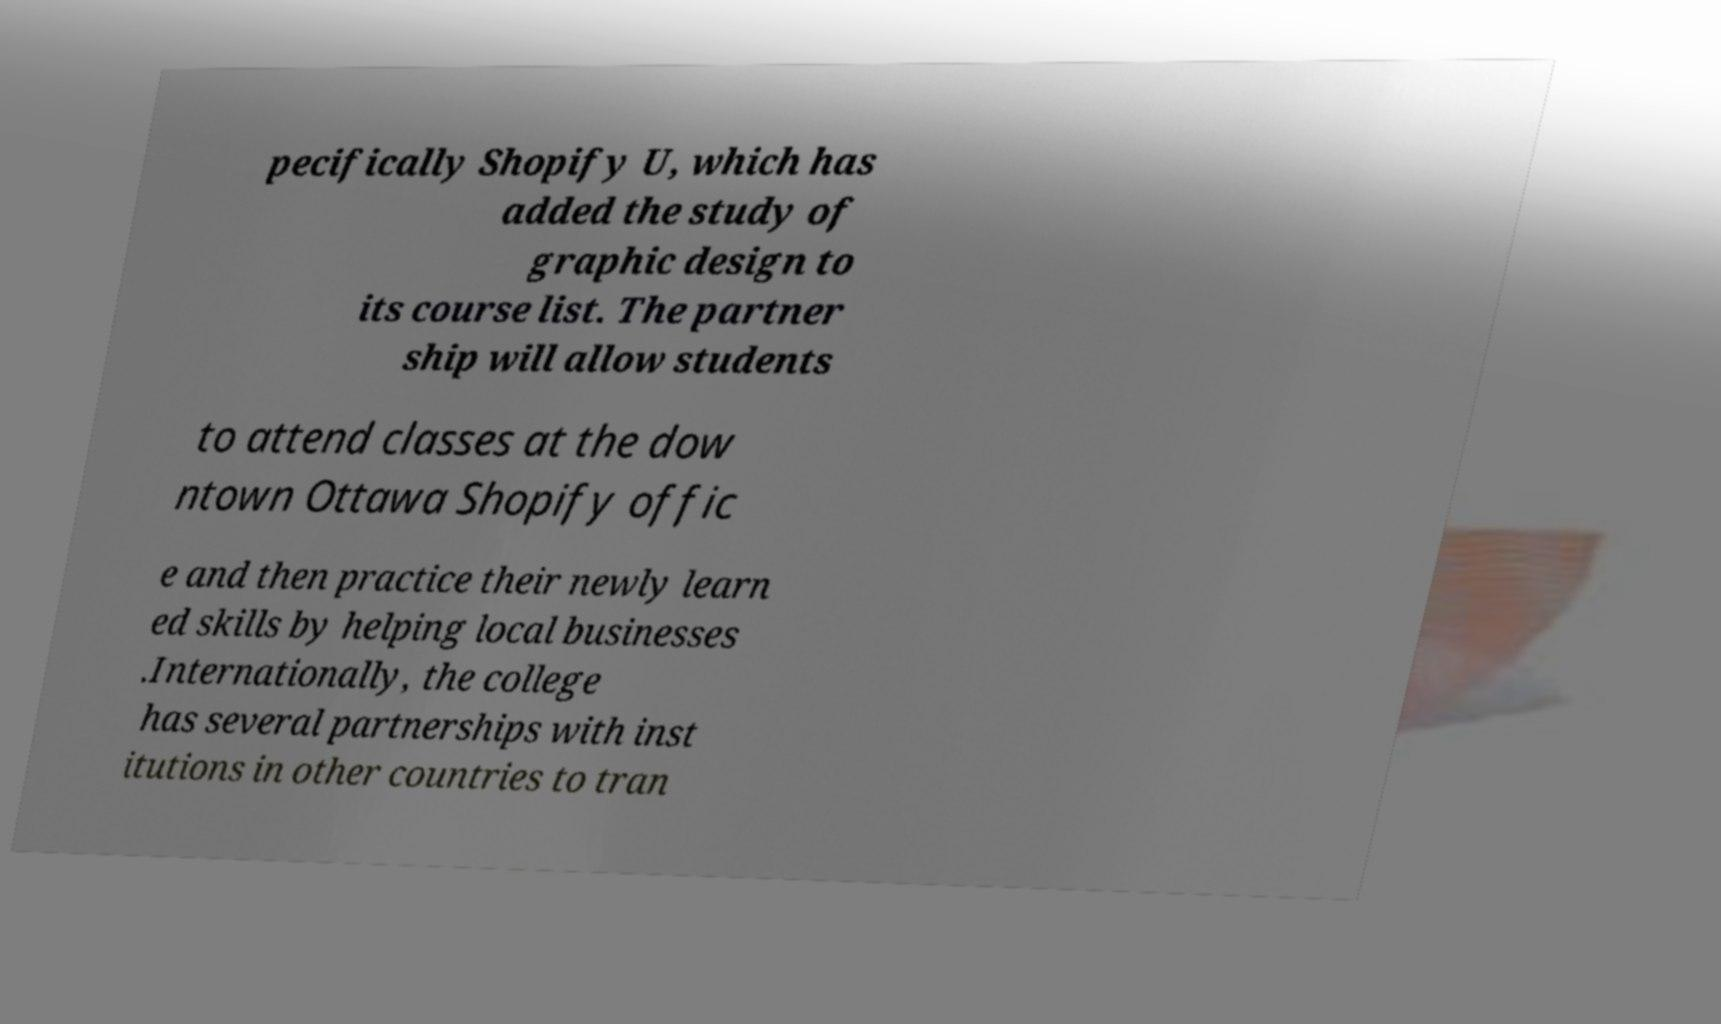Could you extract and type out the text from this image? pecifically Shopify U, which has added the study of graphic design to its course list. The partner ship will allow students to attend classes at the dow ntown Ottawa Shopify offic e and then practice their newly learn ed skills by helping local businesses .Internationally, the college has several partnerships with inst itutions in other countries to tran 